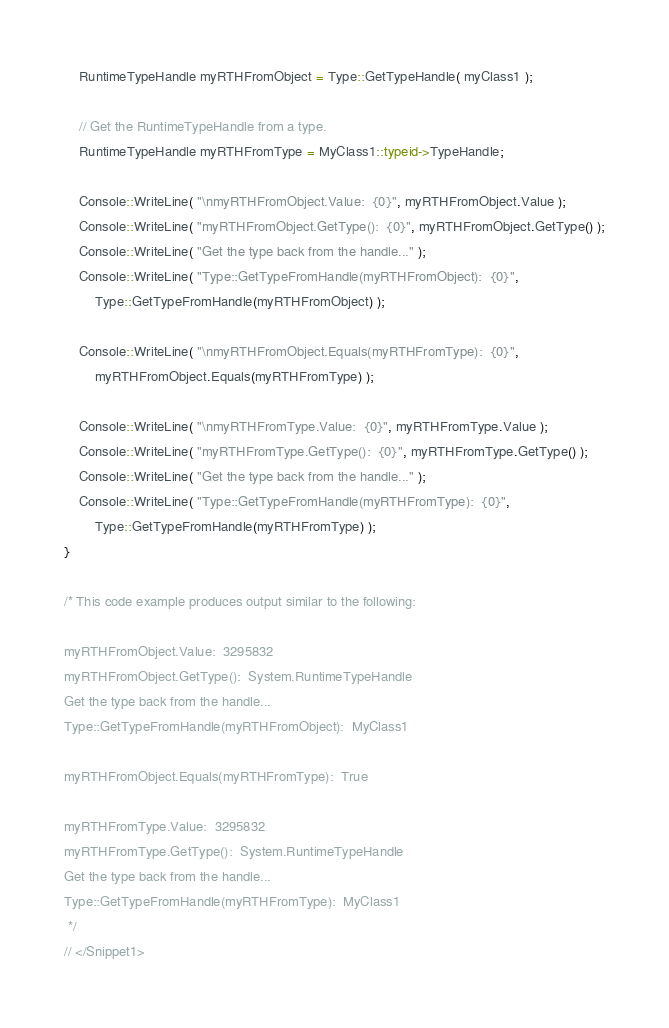<code> <loc_0><loc_0><loc_500><loc_500><_C++_>    RuntimeTypeHandle myRTHFromObject = Type::GetTypeHandle( myClass1 );
   
    // Get the RuntimeTypeHandle from a type.
    RuntimeTypeHandle myRTHFromType = MyClass1::typeid->TypeHandle;

    Console::WriteLine( "\nmyRTHFromObject.Value:  {0}", myRTHFromObject.Value );
    Console::WriteLine( "myRTHFromObject.GetType():  {0}", myRTHFromObject.GetType() );
    Console::WriteLine( "Get the type back from the handle..." );
    Console::WriteLine( "Type::GetTypeFromHandle(myRTHFromObject):  {0}", 
        Type::GetTypeFromHandle(myRTHFromObject) );

    Console::WriteLine( "\nmyRTHFromObject.Equals(myRTHFromType):  {0}", 
        myRTHFromObject.Equals(myRTHFromType) );

    Console::WriteLine( "\nmyRTHFromType.Value:  {0}", myRTHFromType.Value );
    Console::WriteLine( "myRTHFromType.GetType():  {0}", myRTHFromType.GetType() );
    Console::WriteLine( "Get the type back from the handle..." );
    Console::WriteLine( "Type::GetTypeFromHandle(myRTHFromType):  {0}", 
        Type::GetTypeFromHandle(myRTHFromType) );
}

/* This code example produces output similar to the following:

myRTHFromObject.Value:  3295832
myRTHFromObject.GetType():  System.RuntimeTypeHandle
Get the type back from the handle...
Type::GetTypeFromHandle(myRTHFromObject):  MyClass1

myRTHFromObject.Equals(myRTHFromType):  True

myRTHFromType.Value:  3295832
myRTHFromType.GetType():  System.RuntimeTypeHandle
Get the type back from the handle...
Type::GetTypeFromHandle(myRTHFromType):  MyClass1
 */
// </Snippet1>
</code> 